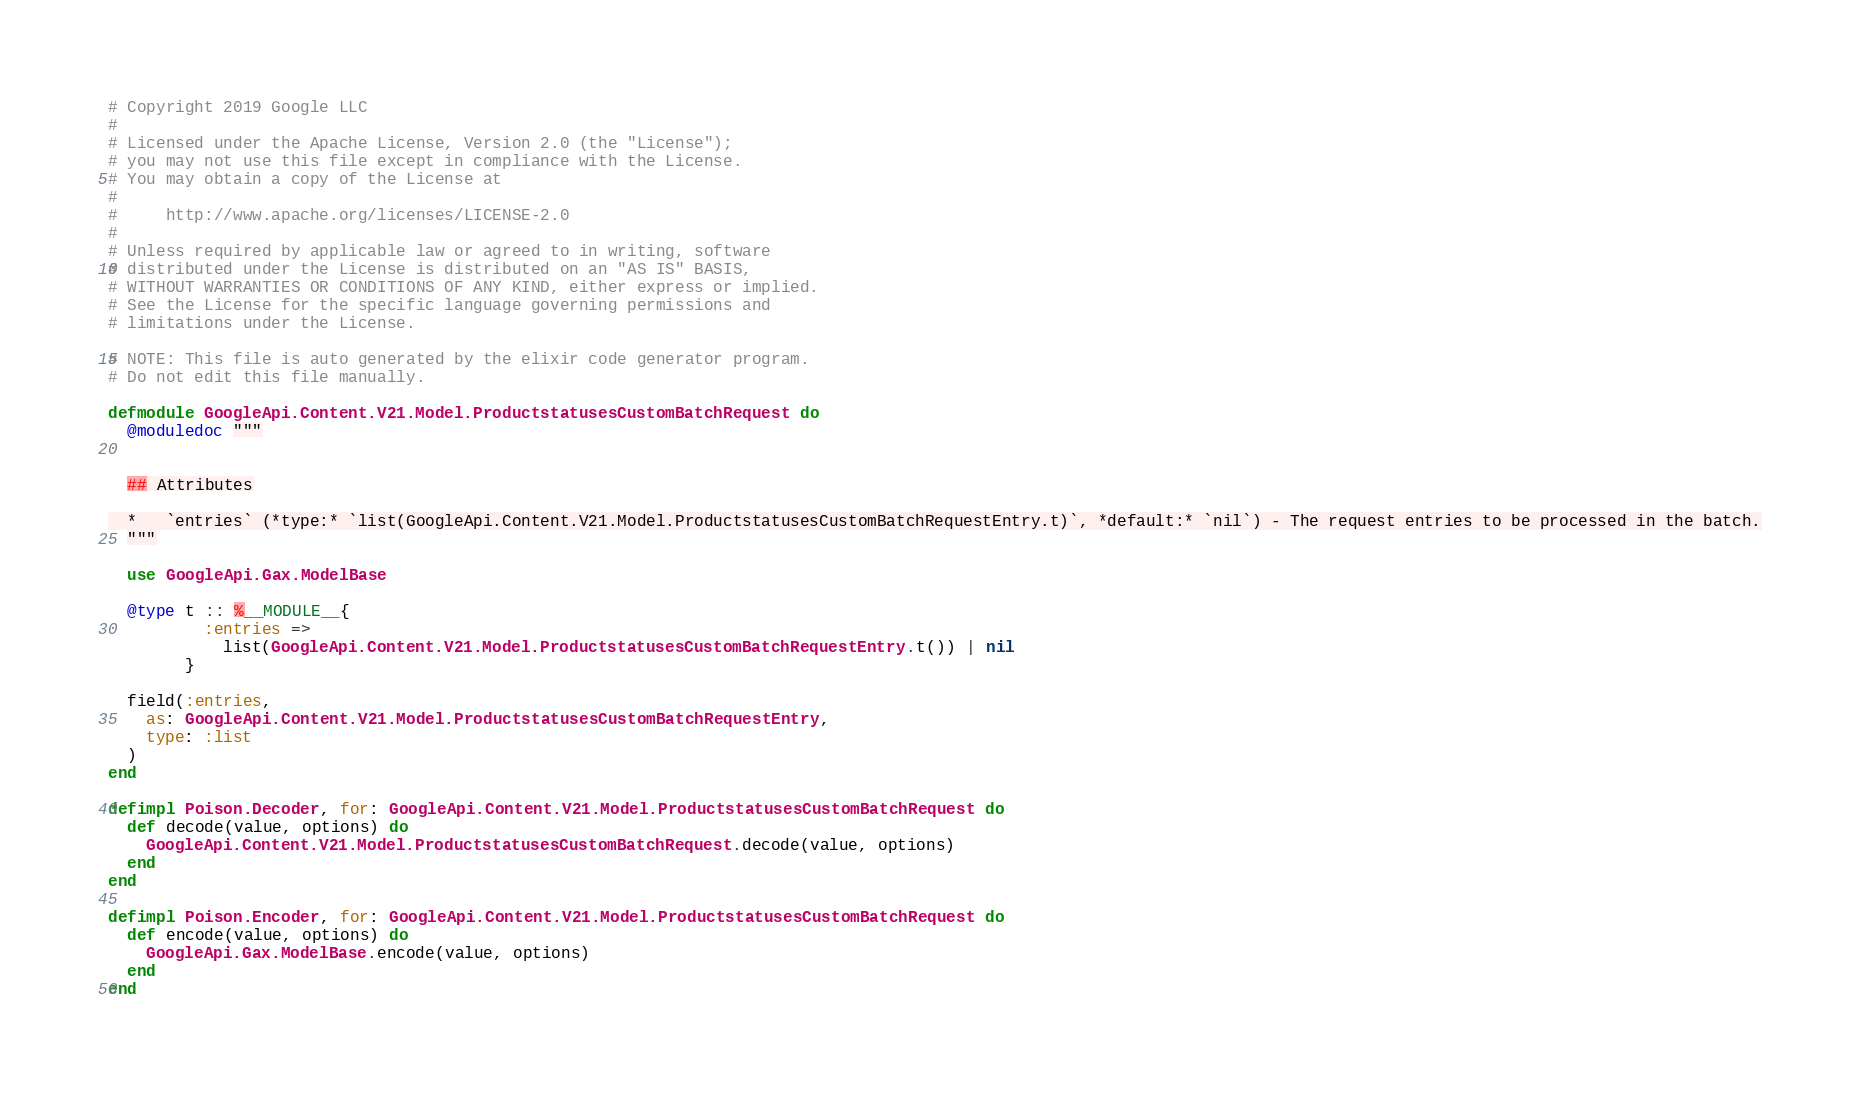<code> <loc_0><loc_0><loc_500><loc_500><_Elixir_># Copyright 2019 Google LLC
#
# Licensed under the Apache License, Version 2.0 (the "License");
# you may not use this file except in compliance with the License.
# You may obtain a copy of the License at
#
#     http://www.apache.org/licenses/LICENSE-2.0
#
# Unless required by applicable law or agreed to in writing, software
# distributed under the License is distributed on an "AS IS" BASIS,
# WITHOUT WARRANTIES OR CONDITIONS OF ANY KIND, either express or implied.
# See the License for the specific language governing permissions and
# limitations under the License.

# NOTE: This file is auto generated by the elixir code generator program.
# Do not edit this file manually.

defmodule GoogleApi.Content.V21.Model.ProductstatusesCustomBatchRequest do
  @moduledoc """


  ## Attributes

  *   `entries` (*type:* `list(GoogleApi.Content.V21.Model.ProductstatusesCustomBatchRequestEntry.t)`, *default:* `nil`) - The request entries to be processed in the batch.
  """

  use GoogleApi.Gax.ModelBase

  @type t :: %__MODULE__{
          :entries =>
            list(GoogleApi.Content.V21.Model.ProductstatusesCustomBatchRequestEntry.t()) | nil
        }

  field(:entries,
    as: GoogleApi.Content.V21.Model.ProductstatusesCustomBatchRequestEntry,
    type: :list
  )
end

defimpl Poison.Decoder, for: GoogleApi.Content.V21.Model.ProductstatusesCustomBatchRequest do
  def decode(value, options) do
    GoogleApi.Content.V21.Model.ProductstatusesCustomBatchRequest.decode(value, options)
  end
end

defimpl Poison.Encoder, for: GoogleApi.Content.V21.Model.ProductstatusesCustomBatchRequest do
  def encode(value, options) do
    GoogleApi.Gax.ModelBase.encode(value, options)
  end
end
</code> 